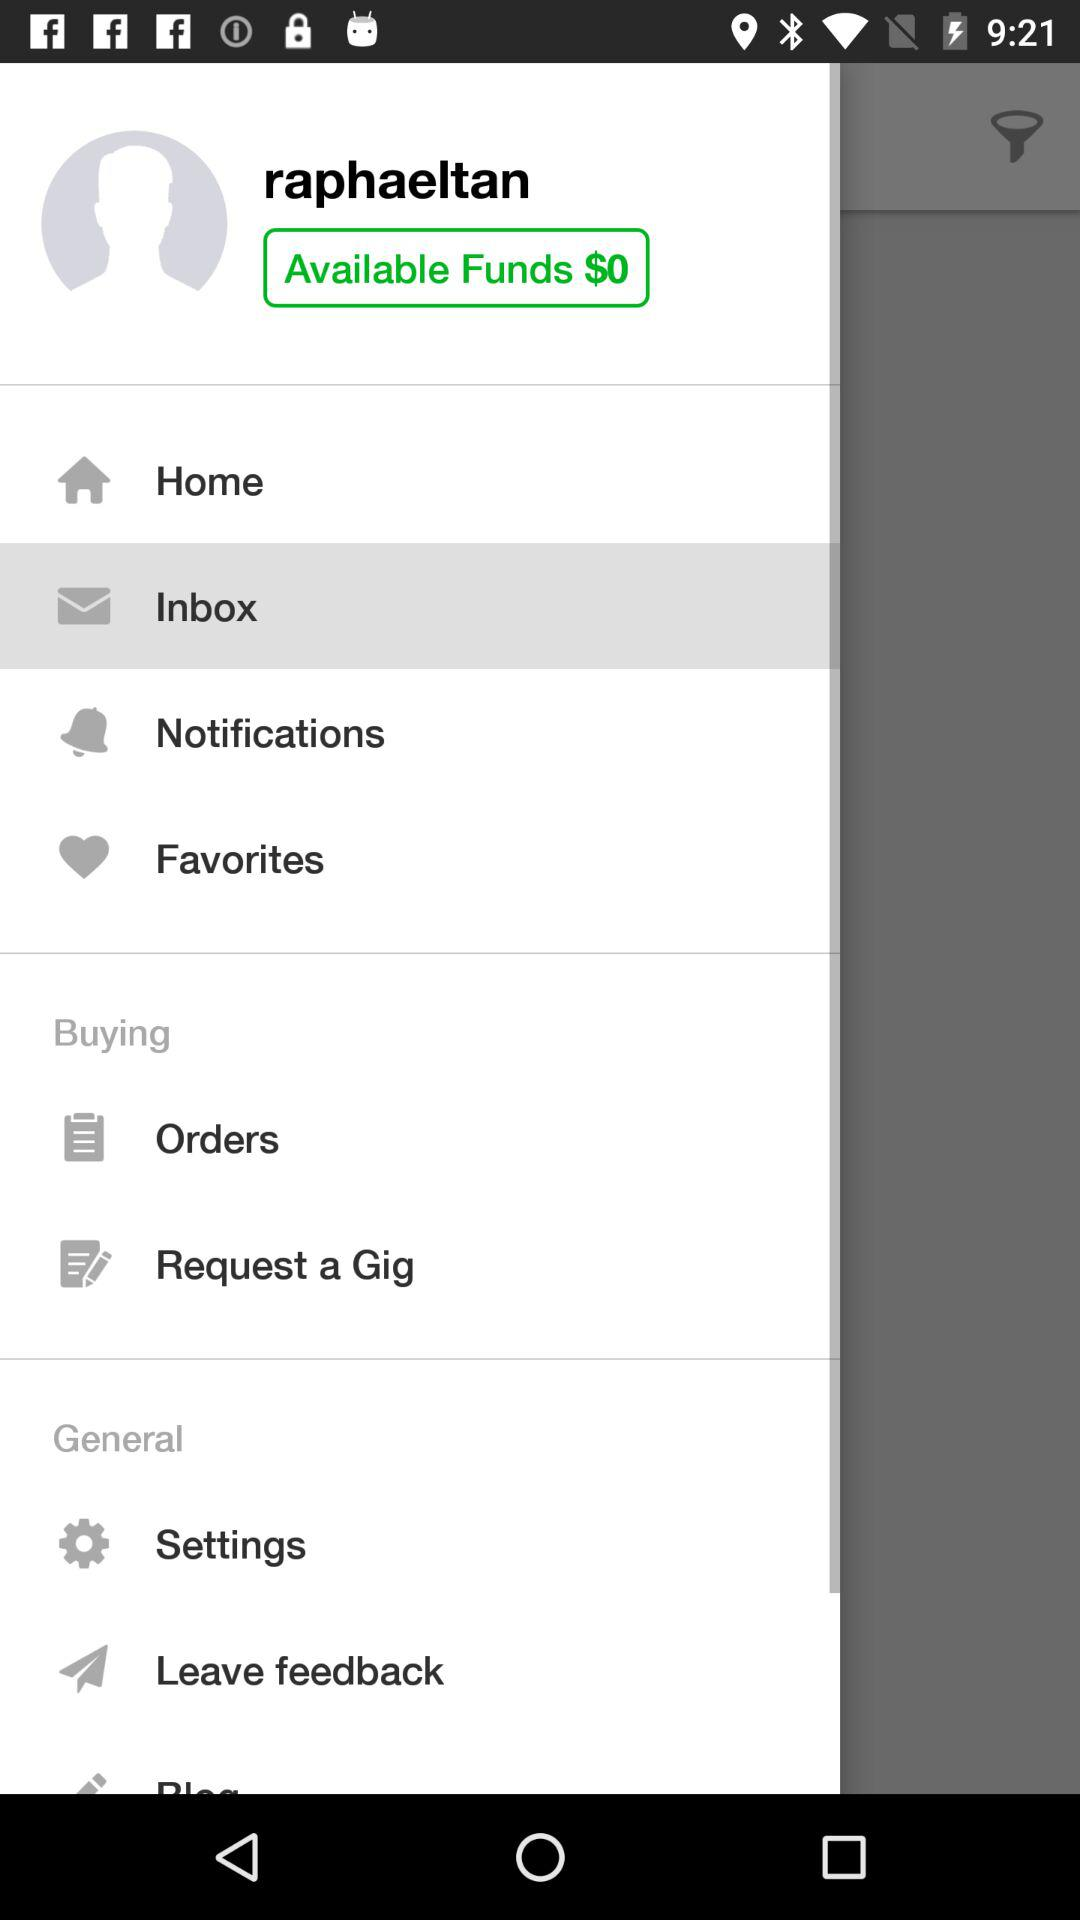What is the profile name? The profile name is "raphaeltan". 